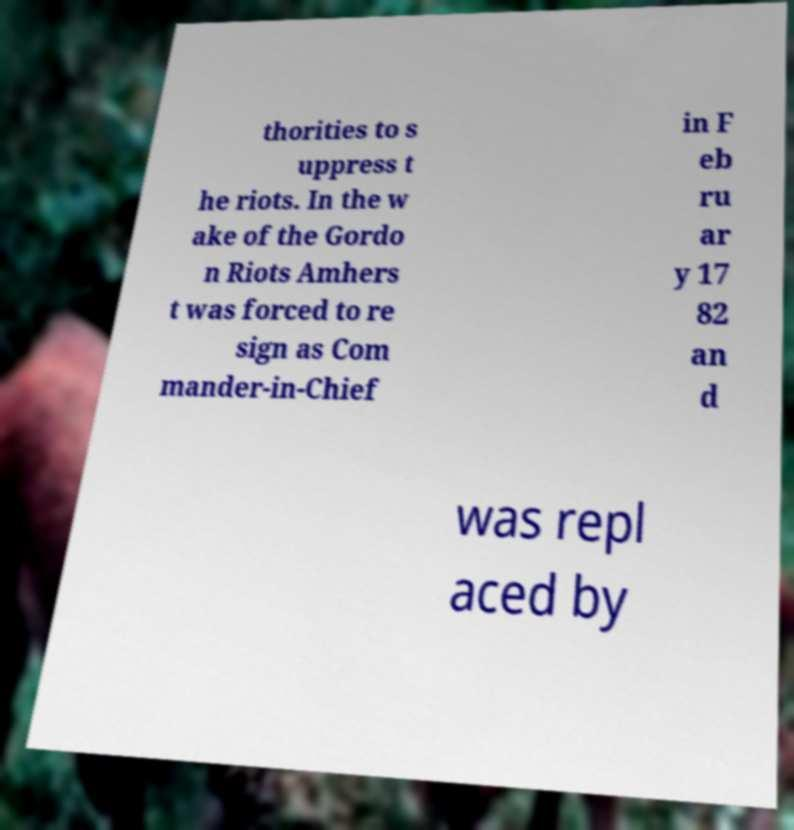Could you extract and type out the text from this image? thorities to s uppress t he riots. In the w ake of the Gordo n Riots Amhers t was forced to re sign as Com mander-in-Chief in F eb ru ar y 17 82 an d was repl aced by 